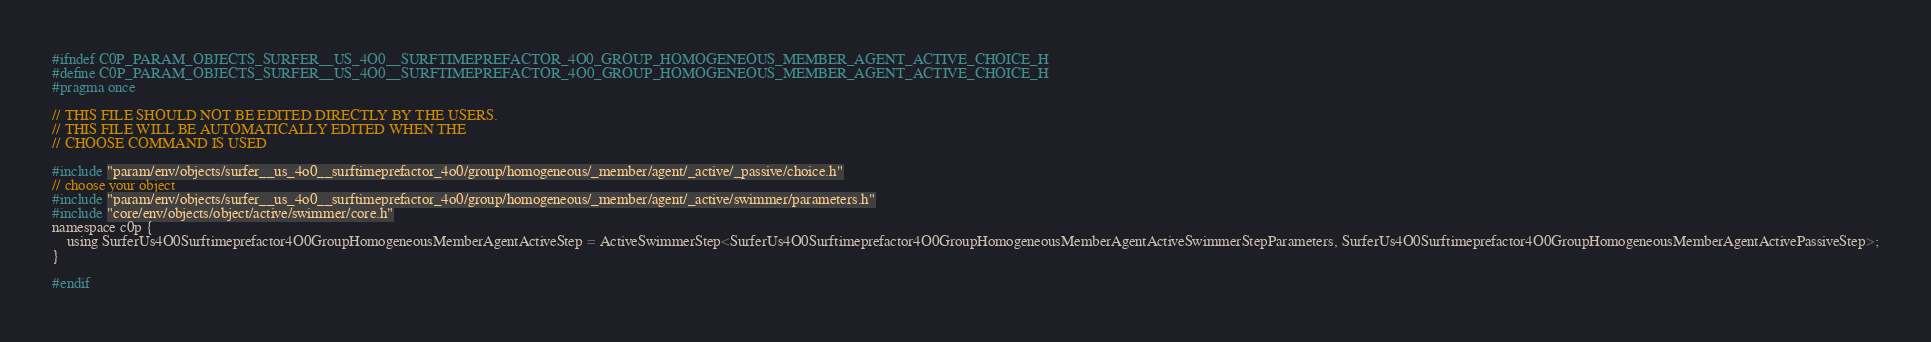Convert code to text. <code><loc_0><loc_0><loc_500><loc_500><_C_>#ifndef C0P_PARAM_OBJECTS_SURFER__US_4O0__SURFTIMEPREFACTOR_4O0_GROUP_HOMOGENEOUS_MEMBER_AGENT_ACTIVE_CHOICE_H
#define C0P_PARAM_OBJECTS_SURFER__US_4O0__SURFTIMEPREFACTOR_4O0_GROUP_HOMOGENEOUS_MEMBER_AGENT_ACTIVE_CHOICE_H
#pragma once

// THIS FILE SHOULD NOT BE EDITED DIRECTLY BY THE USERS.
// THIS FILE WILL BE AUTOMATICALLY EDITED WHEN THE
// CHOOSE COMMAND IS USED

#include "param/env/objects/surfer__us_4o0__surftimeprefactor_4o0/group/homogeneous/_member/agent/_active/_passive/choice.h"
// choose your object
#include "param/env/objects/surfer__us_4o0__surftimeprefactor_4o0/group/homogeneous/_member/agent/_active/swimmer/parameters.h"
#include "core/env/objects/object/active/swimmer/core.h"
namespace c0p {
    using SurferUs4O0Surftimeprefactor4O0GroupHomogeneousMemberAgentActiveStep = ActiveSwimmerStep<SurferUs4O0Surftimeprefactor4O0GroupHomogeneousMemberAgentActiveSwimmerStepParameters, SurferUs4O0Surftimeprefactor4O0GroupHomogeneousMemberAgentActivePassiveStep>;
}

#endif
</code> 